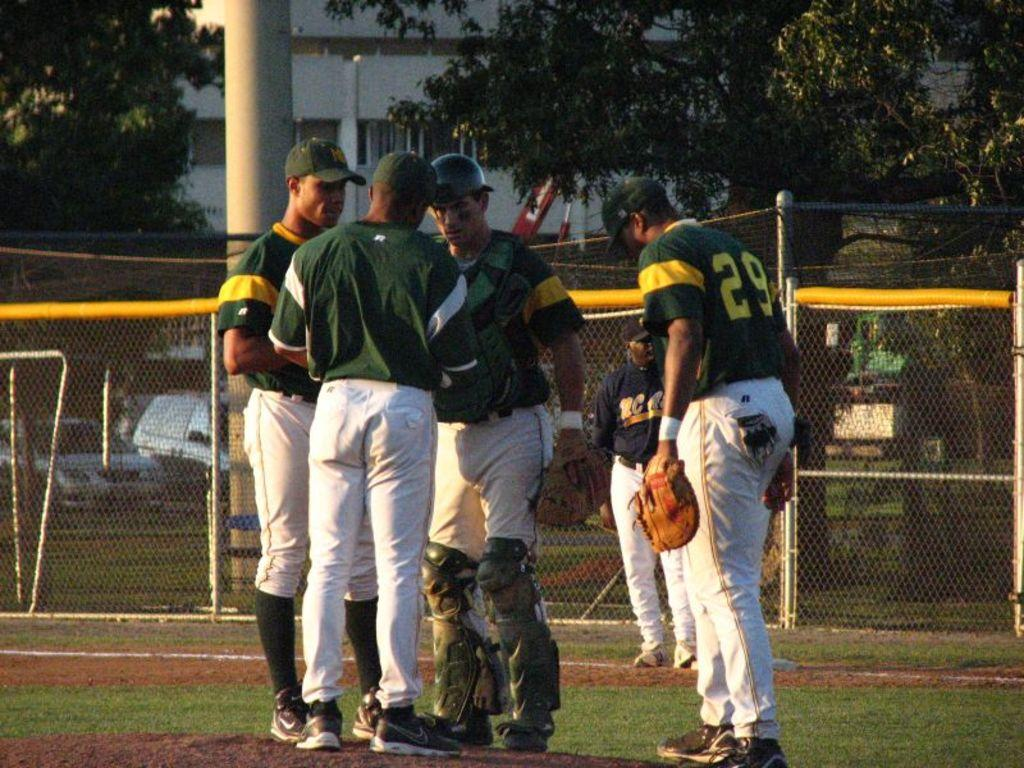<image>
Render a clear and concise summary of the photo. A group of baseball players on the field and one has number 29 on the jersey. 